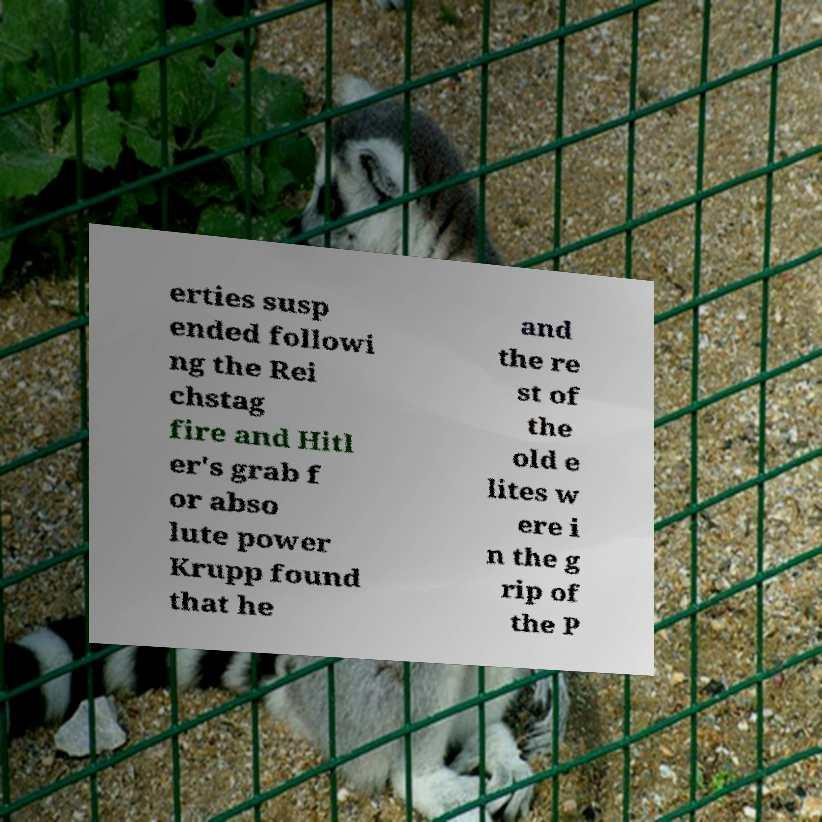For documentation purposes, I need the text within this image transcribed. Could you provide that? erties susp ended followi ng the Rei chstag fire and Hitl er's grab f or abso lute power Krupp found that he and the re st of the old e lites w ere i n the g rip of the P 